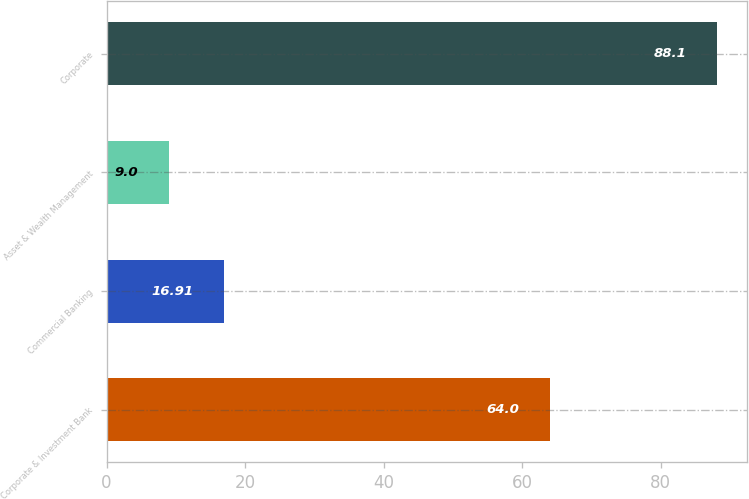Convert chart to OTSL. <chart><loc_0><loc_0><loc_500><loc_500><bar_chart><fcel>Corporate & Investment Bank<fcel>Commercial Banking<fcel>Asset & Wealth Management<fcel>Corporate<nl><fcel>64<fcel>16.91<fcel>9<fcel>88.1<nl></chart> 